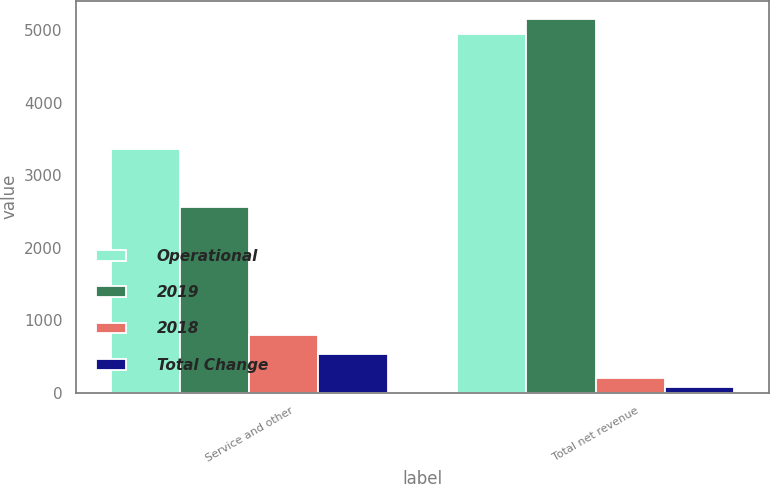<chart> <loc_0><loc_0><loc_500><loc_500><stacked_bar_chart><ecel><fcel>Service and other<fcel>Total net revenue<nl><fcel>Operational<fcel>3357<fcel>4950<nl><fcel>2019<fcel>2564<fcel>5150<nl><fcel>2018<fcel>793<fcel>200<nl><fcel>Total Change<fcel>530<fcel>81<nl></chart> 